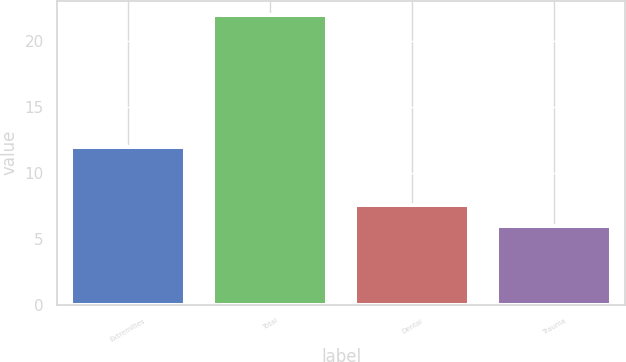<chart> <loc_0><loc_0><loc_500><loc_500><bar_chart><fcel>Extremities<fcel>Total<fcel>Dental<fcel>Trauma<nl><fcel>12<fcel>22<fcel>7.6<fcel>6<nl></chart> 